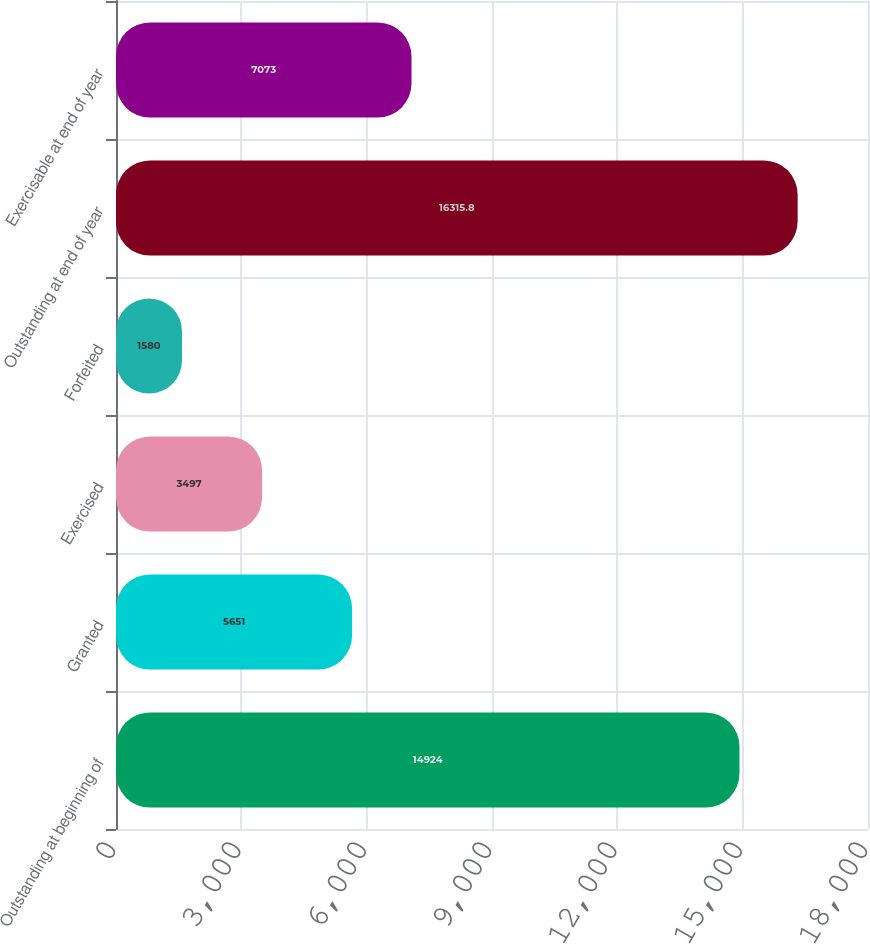Convert chart to OTSL. <chart><loc_0><loc_0><loc_500><loc_500><bar_chart><fcel>Outstanding at beginning of<fcel>Granted<fcel>Exercised<fcel>Forfeited<fcel>Outstanding at end of year<fcel>Exercisable at end of year<nl><fcel>14924<fcel>5651<fcel>3497<fcel>1580<fcel>16315.8<fcel>7073<nl></chart> 